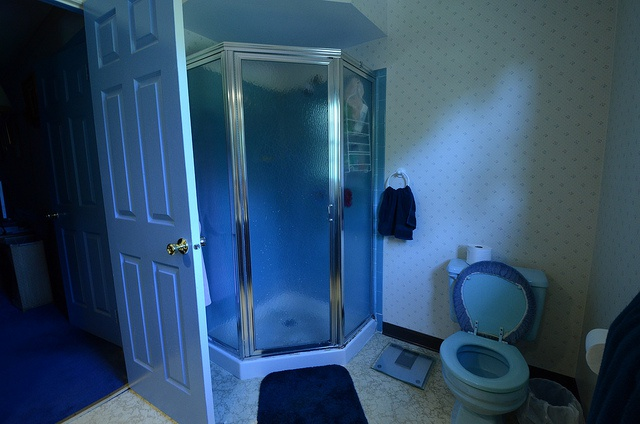Describe the objects in this image and their specific colors. I can see a toilet in black, blue, and navy tones in this image. 